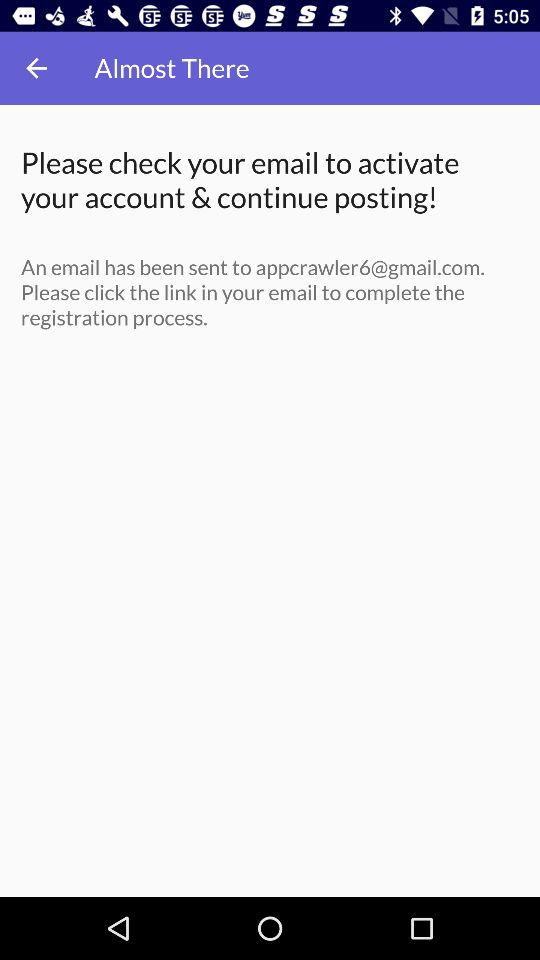What is the email address? The email address is appcrawler6@gmail.com. 